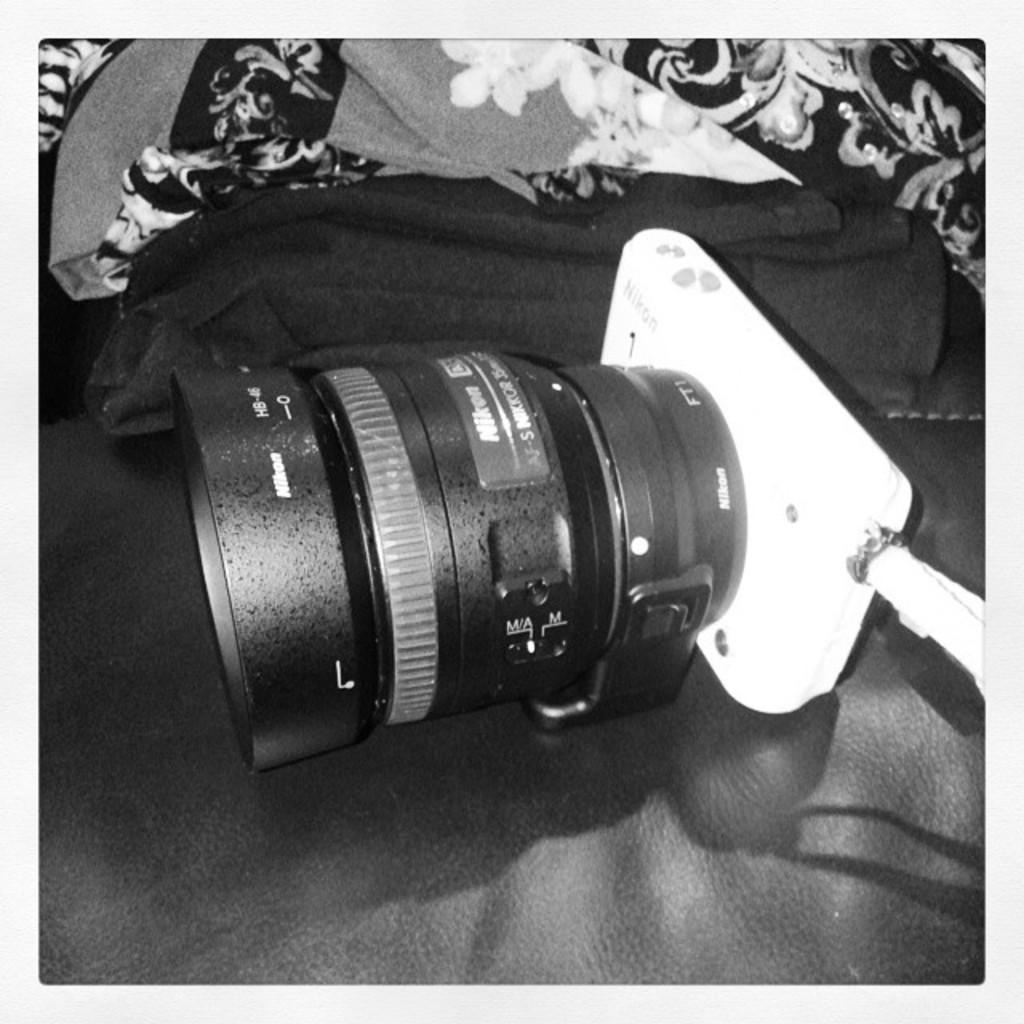What object is the main focus of the image? There is a camera lens in the image. What is the color of the camera lens? The camera lens is black in color. Where is the camera lens placed in the image? The camera lens is placed on a seat. What can be seen in the background of the image? There are clothes and blankets in the background of the image. What verse is written on the camera lens in the image? There is no verse written on the camera lens in the image; it is a black camera lens placed on a seat. 